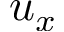Convert formula to latex. <formula><loc_0><loc_0><loc_500><loc_500>u _ { x }</formula> 